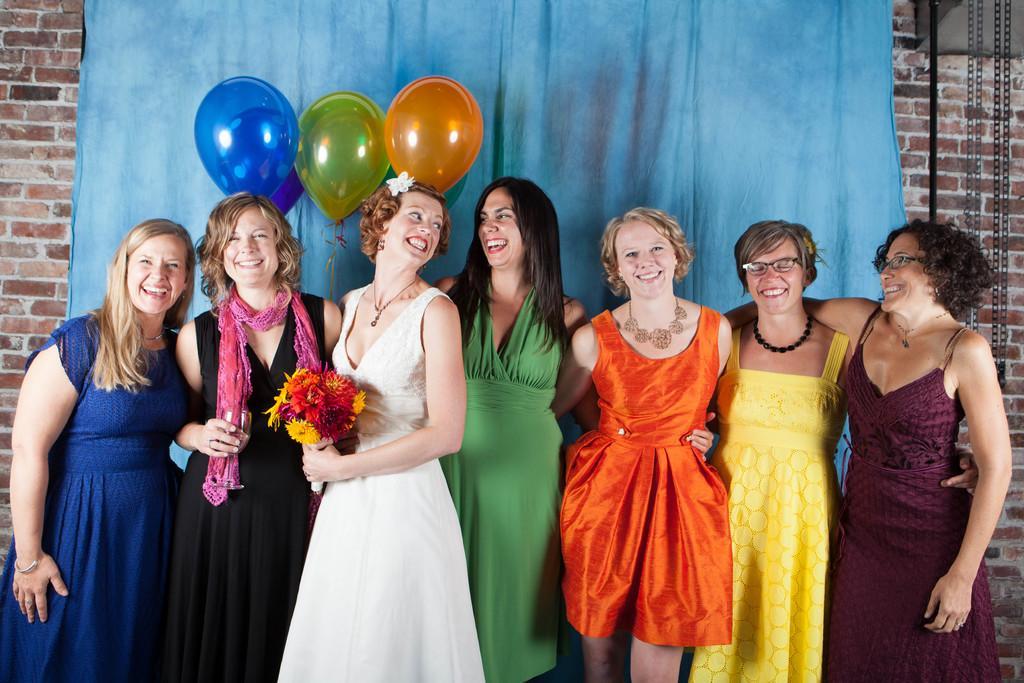Describe this image in one or two sentences. In this image I can see the group of people with different color dresses and two people with the specs. I can see one person holding the flower bouquet and the flowers are in yellow, red and pink color. In the background I can see the balloons and the blue color cloth. I can also see the chain and brown color brick wall. 